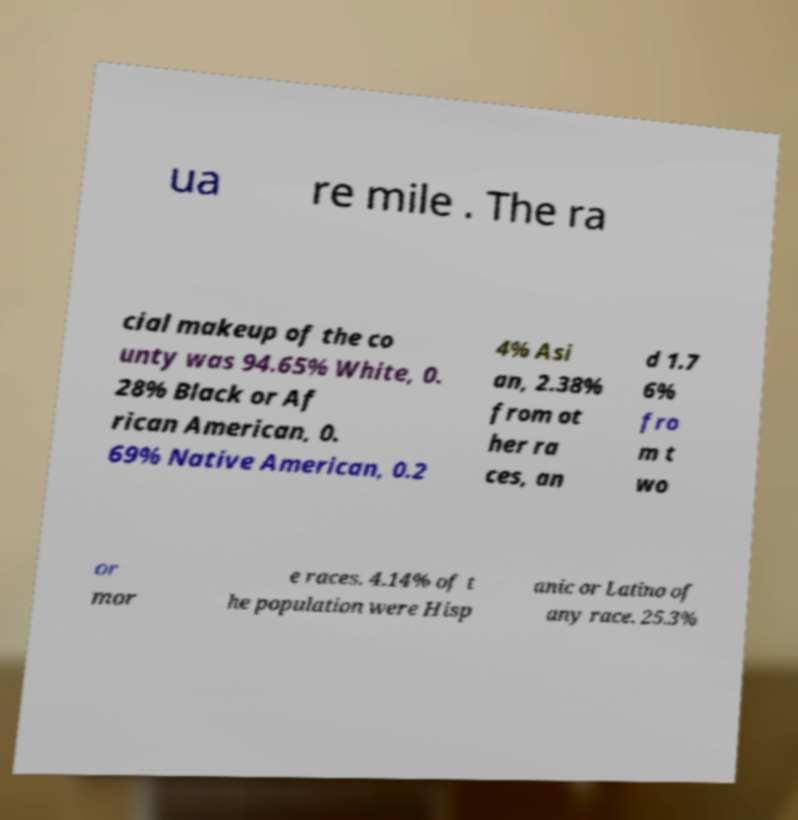Could you extract and type out the text from this image? ua re mile . The ra cial makeup of the co unty was 94.65% White, 0. 28% Black or Af rican American, 0. 69% Native American, 0.2 4% Asi an, 2.38% from ot her ra ces, an d 1.7 6% fro m t wo or mor e races. 4.14% of t he population were Hisp anic or Latino of any race. 25.3% 